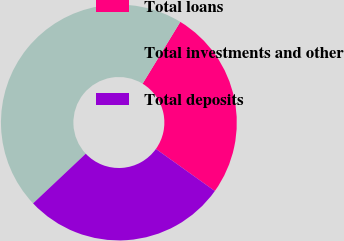Convert chart to OTSL. <chart><loc_0><loc_0><loc_500><loc_500><pie_chart><fcel>Total loans<fcel>Total investments and other<fcel>Total deposits<nl><fcel>26.14%<fcel>45.75%<fcel>28.1%<nl></chart> 